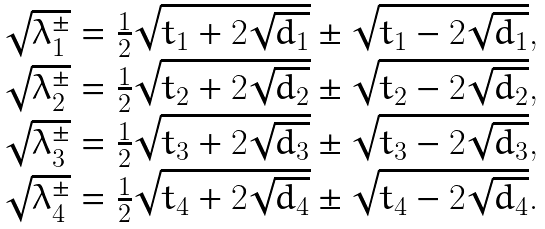<formula> <loc_0><loc_0><loc_500><loc_500>\begin{array} { l } \sqrt { \lambda _ { 1 } ^ { \pm } } = \frac { 1 } { 2 } \sqrt { { t _ { 1 } } + 2 \sqrt { d _ { 1 } } } \pm \sqrt { { t _ { 1 } } - 2 \sqrt { d _ { 1 } } } , \\ \sqrt { \lambda _ { 2 } ^ { \pm } } = \frac { 1 } { 2 } \sqrt { { t _ { 2 } } + 2 \sqrt { d _ { 2 } } } \pm \sqrt { { t _ { 2 } } - 2 \sqrt { d _ { 2 } } } , \\ \sqrt { \lambda _ { 3 } ^ { \pm } } = \frac { 1 } { 2 } \sqrt { { t _ { 3 } } + 2 \sqrt { d _ { 3 } } } \pm \sqrt { { t _ { 3 } } - 2 \sqrt { d _ { 3 } } } , \\ \sqrt { \lambda _ { 4 } ^ { \pm } } = \frac { 1 } { 2 } \sqrt { { t _ { 4 } } + 2 \sqrt { d _ { 4 } } } \pm \sqrt { { t _ { 4 } } - 2 \sqrt { d _ { 4 } } } . \end{array}</formula> 